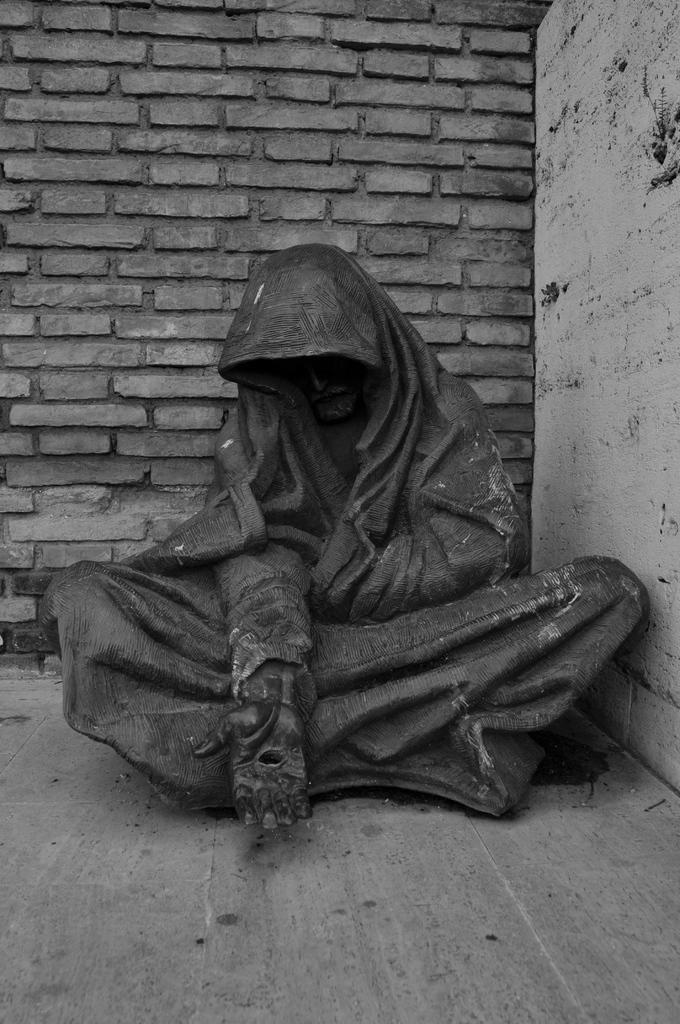What is the color scheme of the image? The image is black and white. What is the main subject in the image? There is a statue in the image. What is the statue resting on? The statue is on a wooden surface. What can be seen in the background of the image? There is a wall in the background of the image. What type of dinner is being served on the wooden surface next to the statue? There is no dinner or any food present in the image; it only features a black and white statue on a wooden surface with a wall in the background. 